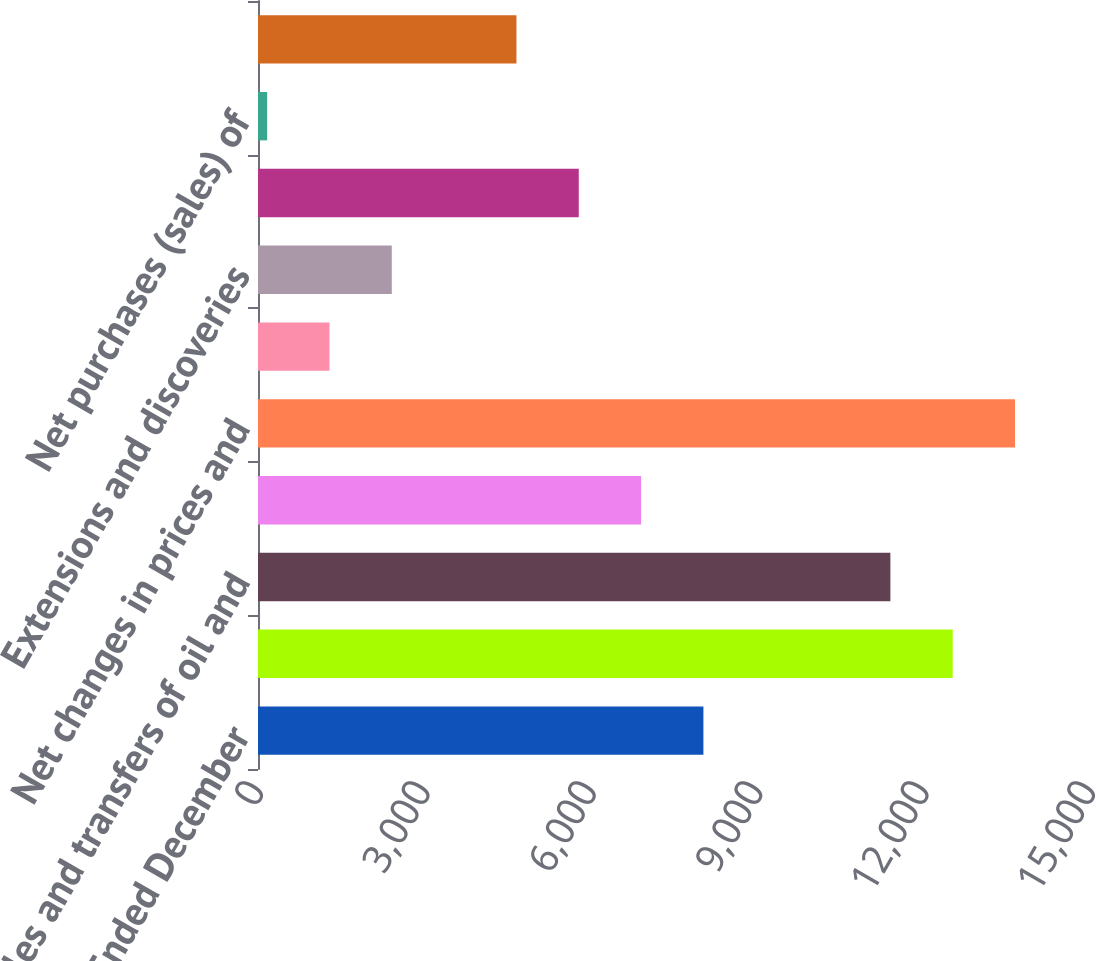Convert chart. <chart><loc_0><loc_0><loc_500><loc_500><bar_chart><fcel>For the Years Ended December<fcel>Standardized measure of<fcel>Sales and transfers of oil and<fcel>Development costs incurred<fcel>Net changes in prices and<fcel>Net change in estimated future<fcel>Extensions and discoveries<fcel>Revisions of previous oil and<fcel>Net purchases (sales) of<fcel>Accretion of discount<nl><fcel>8030.2<fcel>12524.6<fcel>11401<fcel>6906.6<fcel>13648.2<fcel>1288.6<fcel>2412.2<fcel>5783<fcel>165<fcel>4659.4<nl></chart> 